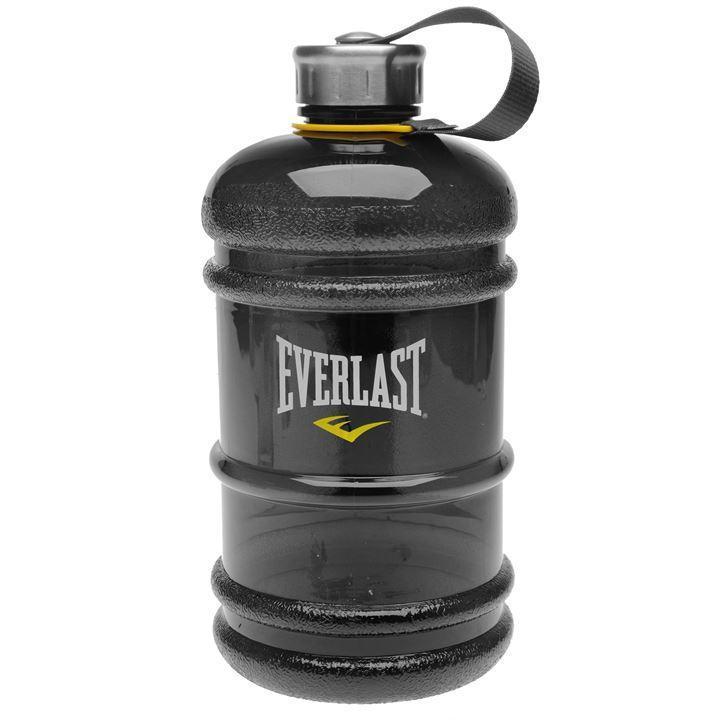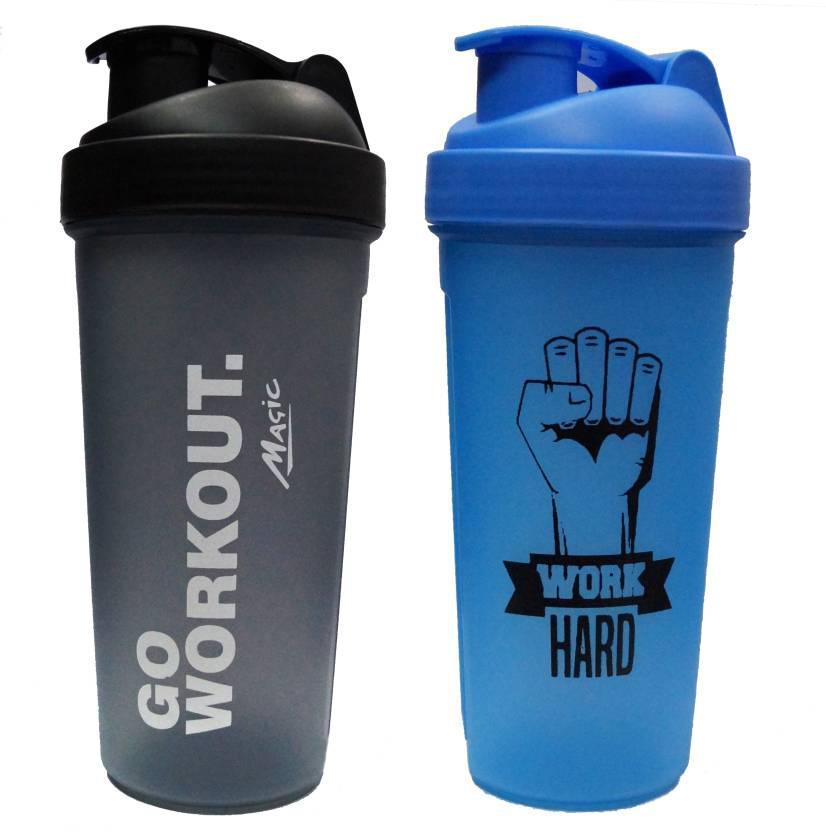The first image is the image on the left, the second image is the image on the right. Evaluate the accuracy of this statement regarding the images: "At least one water bottle is jug-shaped with a built-in side handle and a flip top, and one water bottle is hot pink.". Is it true? Answer yes or no. No. The first image is the image on the left, the second image is the image on the right. Given the left and right images, does the statement "There are three plastic drinking containers with lids." hold true? Answer yes or no. Yes. 